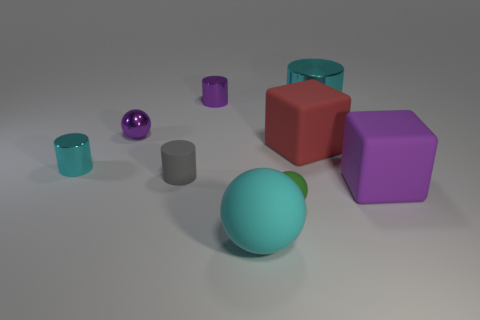There is a small cylinder that is the same color as the shiny ball; what is it made of?
Your answer should be very brief. Metal. There is a metallic thing to the right of the small purple metallic cylinder; what shape is it?
Keep it short and to the point. Cylinder. There is a big object that is in front of the purple rubber cube; does it have the same color as the tiny matte ball?
Provide a succinct answer. No. Are there fewer tiny green balls that are in front of the green ball than small yellow shiny cylinders?
Offer a very short reply. No. There is another ball that is the same material as the cyan sphere; what color is it?
Your response must be concise. Green. What is the size of the block on the left side of the purple rubber thing?
Offer a very short reply. Large. Is the material of the small gray cylinder the same as the green thing?
Provide a succinct answer. Yes. Are there any small shiny balls that are on the right side of the tiny ball left of the small shiny cylinder behind the red block?
Your response must be concise. No. The big cylinder has what color?
Offer a very short reply. Cyan. The metal sphere that is the same size as the green rubber sphere is what color?
Ensure brevity in your answer.  Purple. 